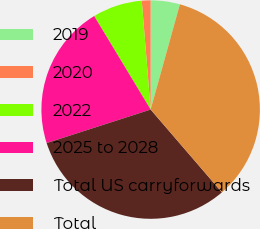<chart> <loc_0><loc_0><loc_500><loc_500><pie_chart><fcel>2019<fcel>2020<fcel>2022<fcel>2025 to 2028<fcel>Total US carryforwards<fcel>Total<nl><fcel>4.32%<fcel>1.29%<fcel>7.35%<fcel>21.32%<fcel>31.35%<fcel>34.37%<nl></chart> 